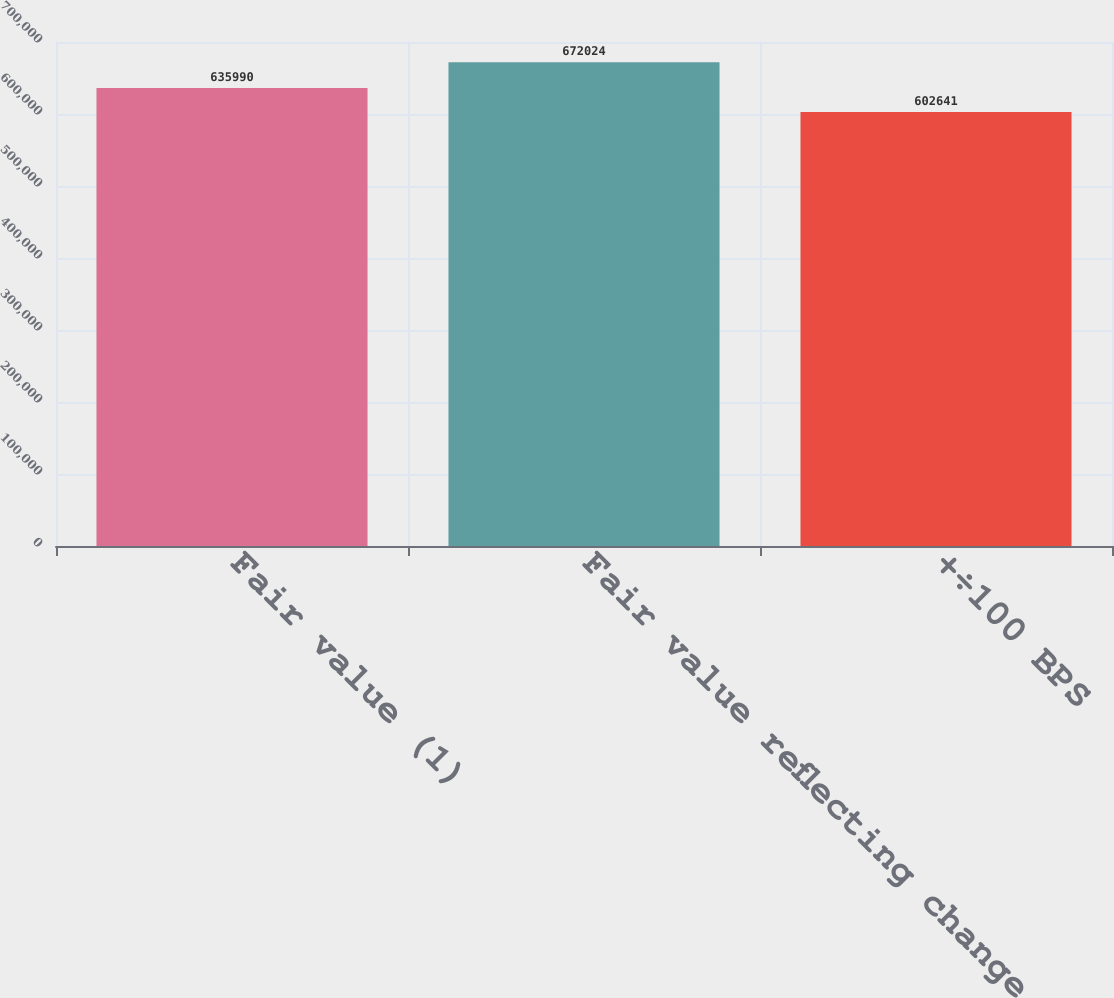<chart> <loc_0><loc_0><loc_500><loc_500><bar_chart><fcel>Fair value (1)<fcel>Fair value reflecting change<fcel>+÷100 BPS<nl><fcel>635990<fcel>672024<fcel>602641<nl></chart> 